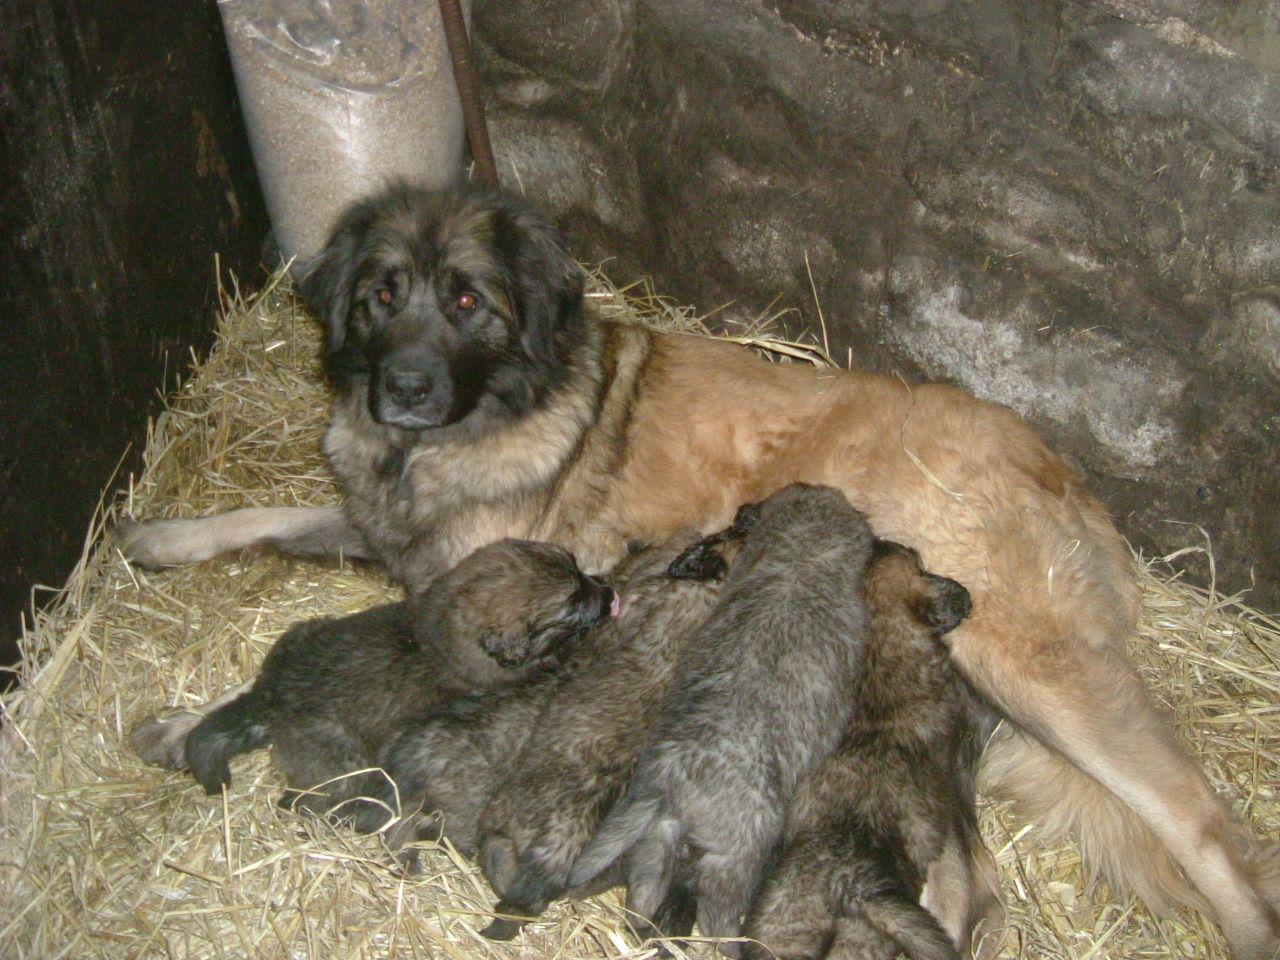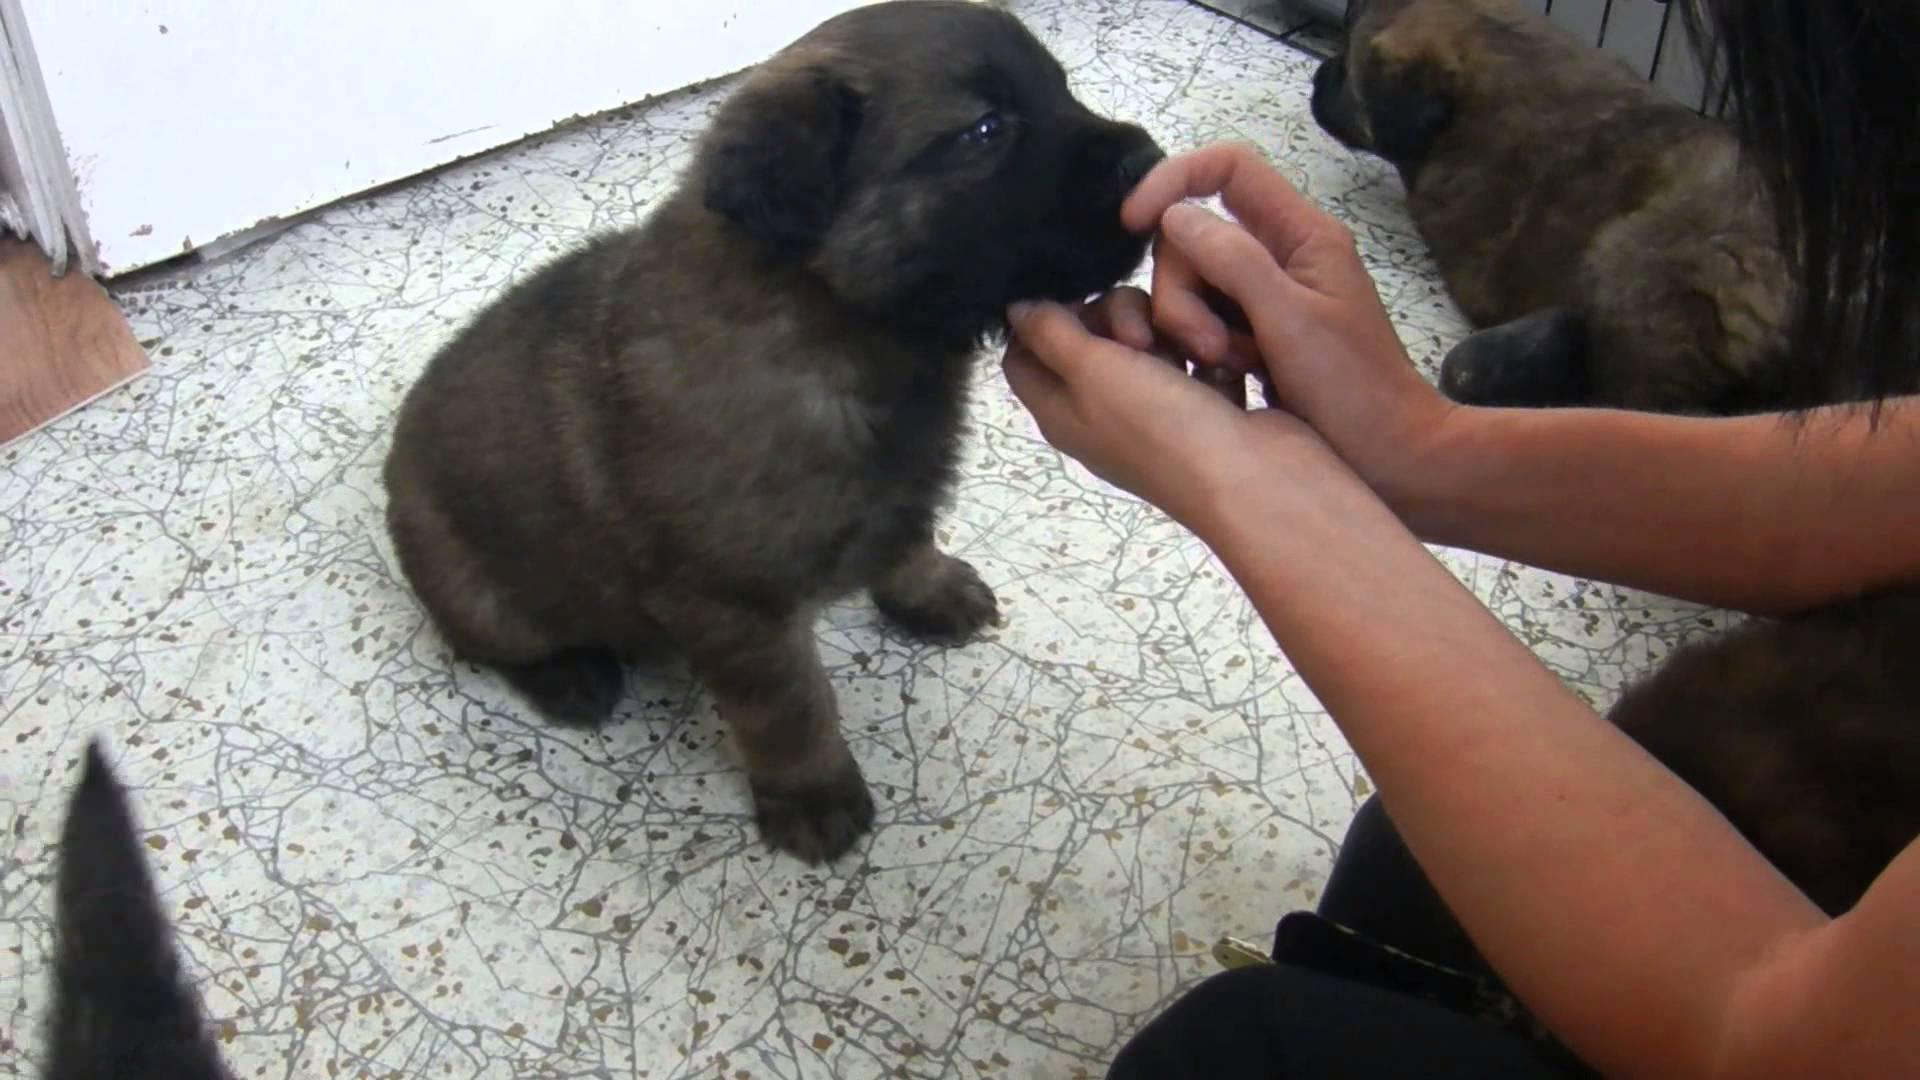The first image is the image on the left, the second image is the image on the right. Considering the images on both sides, is "An image shows at least one puppy on a stone-type floor with a pattern that includes square shapes." valid? Answer yes or no. No. 